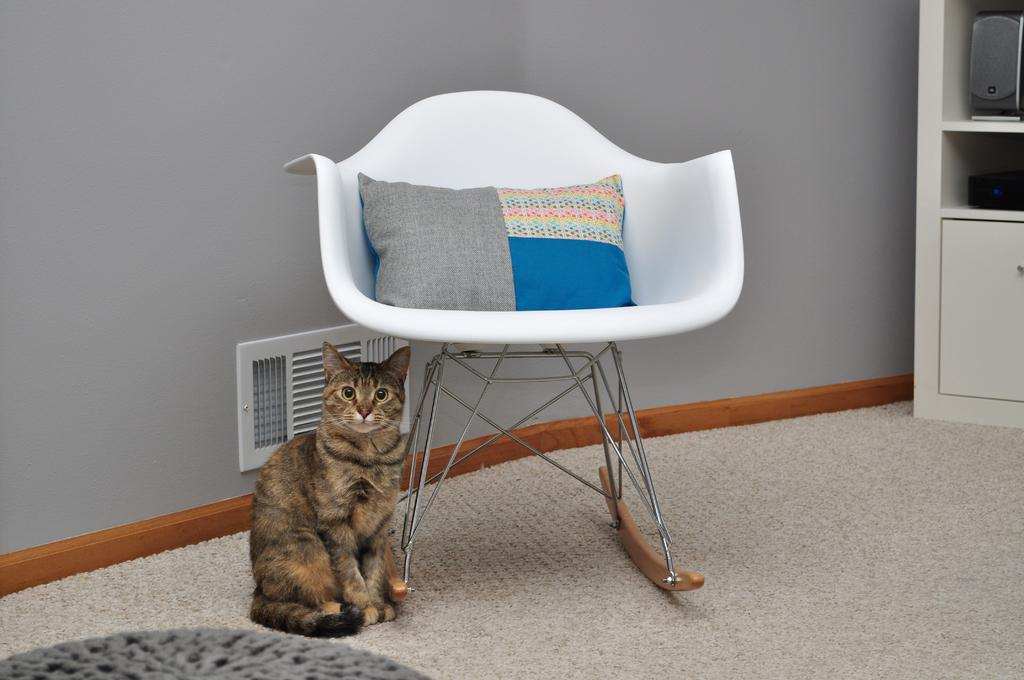What type of furniture is in the image? There is a chair with a cushion in the image. What is the cat doing in the image? The cat is sitting on the floor beside the chair. How many ladybugs are crawling on the chair cushion in the image? There are no ladybugs present in the image; only the chair and the cat are visible. 